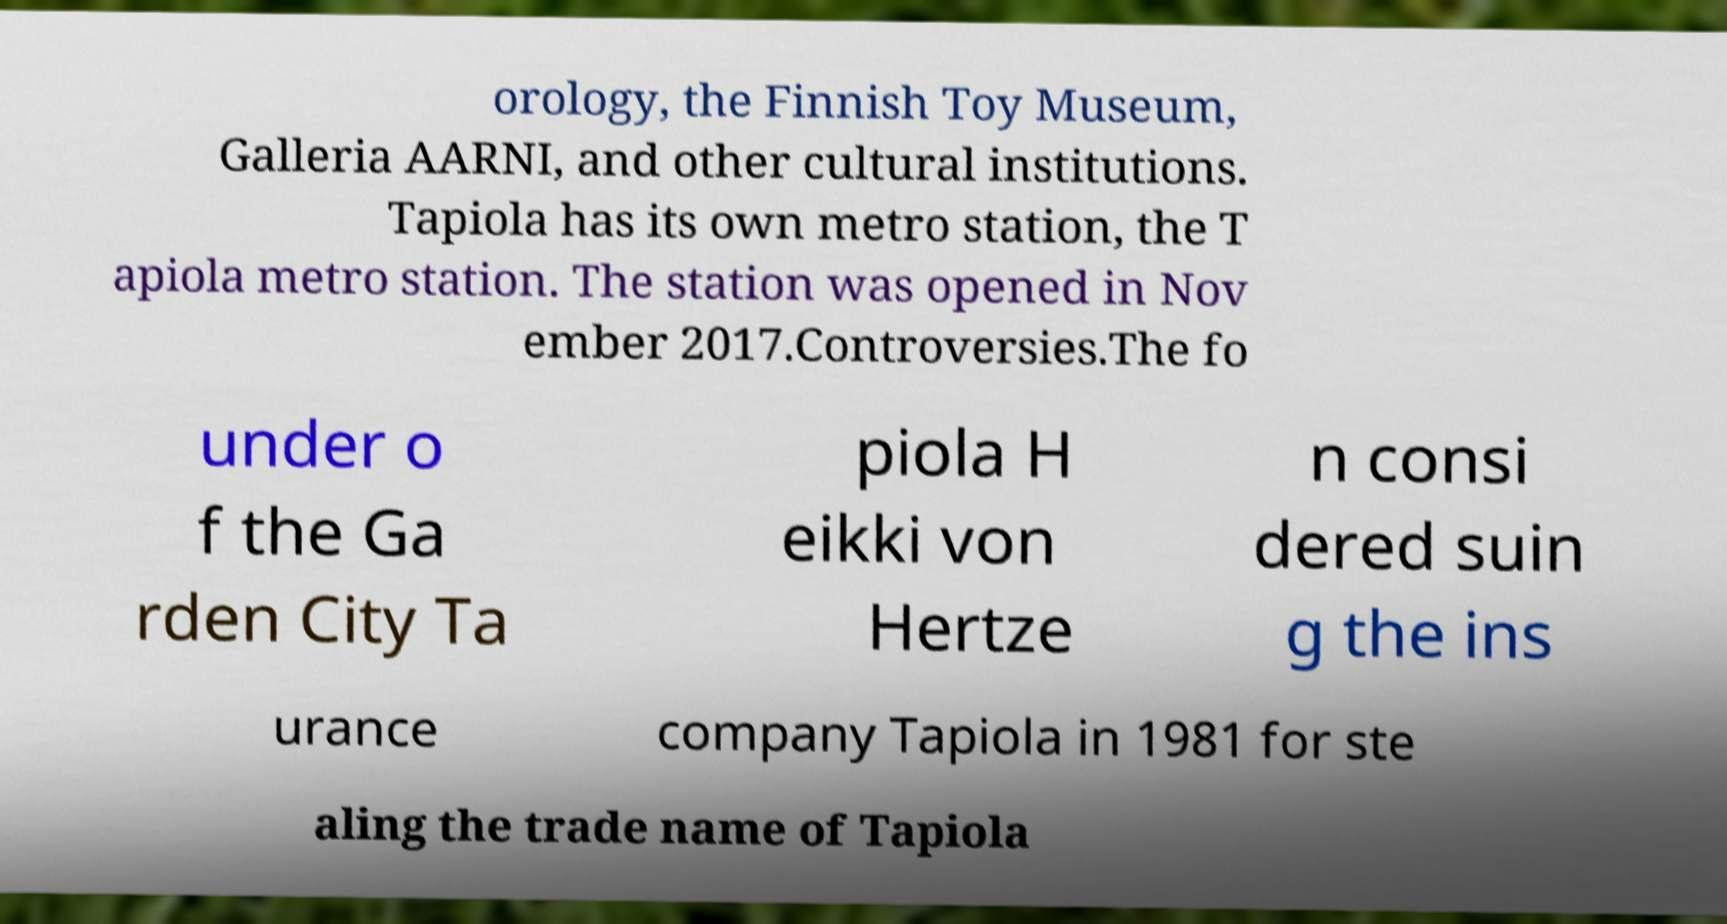Could you extract and type out the text from this image? orology, the Finnish Toy Museum, Galleria AARNI, and other cultural institutions. Tapiola has its own metro station, the T apiola metro station. The station was opened in Nov ember 2017.Controversies.The fo under o f the Ga rden City Ta piola H eikki von Hertze n consi dered suin g the ins urance company Tapiola in 1981 for ste aling the trade name of Tapiola 